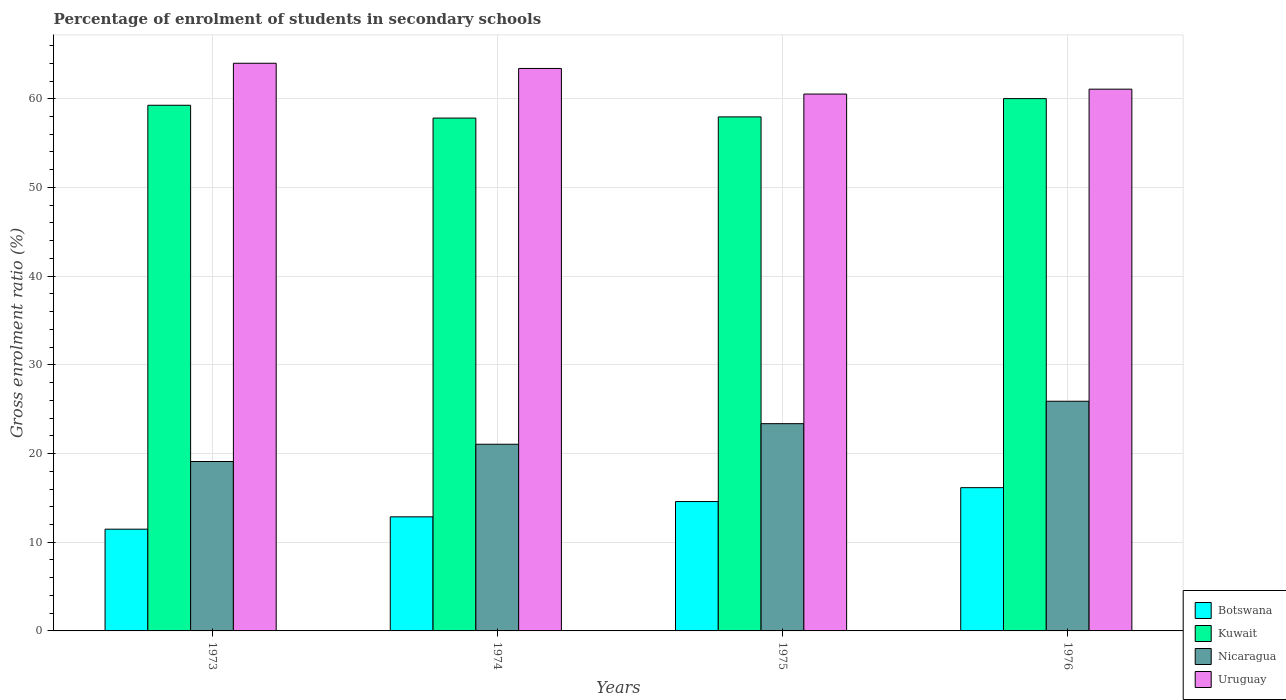How many groups of bars are there?
Give a very brief answer. 4. Are the number of bars on each tick of the X-axis equal?
Make the answer very short. Yes. How many bars are there on the 1st tick from the left?
Offer a terse response. 4. How many bars are there on the 3rd tick from the right?
Ensure brevity in your answer.  4. What is the label of the 1st group of bars from the left?
Give a very brief answer. 1973. In how many cases, is the number of bars for a given year not equal to the number of legend labels?
Offer a terse response. 0. What is the percentage of students enrolled in secondary schools in Kuwait in 1976?
Ensure brevity in your answer.  60.01. Across all years, what is the maximum percentage of students enrolled in secondary schools in Botswana?
Offer a terse response. 16.15. Across all years, what is the minimum percentage of students enrolled in secondary schools in Nicaragua?
Provide a succinct answer. 19.1. In which year was the percentage of students enrolled in secondary schools in Kuwait maximum?
Provide a succinct answer. 1976. In which year was the percentage of students enrolled in secondary schools in Uruguay minimum?
Provide a succinct answer. 1975. What is the total percentage of students enrolled in secondary schools in Uruguay in the graph?
Keep it short and to the point. 249.03. What is the difference between the percentage of students enrolled in secondary schools in Uruguay in 1973 and that in 1976?
Give a very brief answer. 2.92. What is the difference between the percentage of students enrolled in secondary schools in Nicaragua in 1975 and the percentage of students enrolled in secondary schools in Botswana in 1974?
Your answer should be very brief. 10.51. What is the average percentage of students enrolled in secondary schools in Uruguay per year?
Provide a short and direct response. 62.26. In the year 1975, what is the difference between the percentage of students enrolled in secondary schools in Botswana and percentage of students enrolled in secondary schools in Nicaragua?
Give a very brief answer. -8.78. What is the ratio of the percentage of students enrolled in secondary schools in Nicaragua in 1974 to that in 1976?
Keep it short and to the point. 0.81. Is the difference between the percentage of students enrolled in secondary schools in Botswana in 1975 and 1976 greater than the difference between the percentage of students enrolled in secondary schools in Nicaragua in 1975 and 1976?
Ensure brevity in your answer.  Yes. What is the difference between the highest and the second highest percentage of students enrolled in secondary schools in Nicaragua?
Offer a very short reply. 2.53. What is the difference between the highest and the lowest percentage of students enrolled in secondary schools in Botswana?
Provide a succinct answer. 4.68. Is the sum of the percentage of students enrolled in secondary schools in Uruguay in 1974 and 1976 greater than the maximum percentage of students enrolled in secondary schools in Kuwait across all years?
Offer a very short reply. Yes. Is it the case that in every year, the sum of the percentage of students enrolled in secondary schools in Kuwait and percentage of students enrolled in secondary schools in Nicaragua is greater than the sum of percentage of students enrolled in secondary schools in Botswana and percentage of students enrolled in secondary schools in Uruguay?
Your answer should be compact. Yes. What does the 3rd bar from the left in 1976 represents?
Keep it short and to the point. Nicaragua. What does the 4th bar from the right in 1975 represents?
Make the answer very short. Botswana. How are the legend labels stacked?
Your response must be concise. Vertical. What is the title of the graph?
Make the answer very short. Percentage of enrolment of students in secondary schools. Does "High income: OECD" appear as one of the legend labels in the graph?
Offer a very short reply. No. What is the Gross enrolment ratio (%) of Botswana in 1973?
Your answer should be compact. 11.47. What is the Gross enrolment ratio (%) of Kuwait in 1973?
Your response must be concise. 59.27. What is the Gross enrolment ratio (%) in Nicaragua in 1973?
Keep it short and to the point. 19.1. What is the Gross enrolment ratio (%) of Uruguay in 1973?
Make the answer very short. 64. What is the Gross enrolment ratio (%) in Botswana in 1974?
Your answer should be very brief. 12.86. What is the Gross enrolment ratio (%) in Kuwait in 1974?
Your answer should be compact. 57.82. What is the Gross enrolment ratio (%) of Nicaragua in 1974?
Make the answer very short. 21.05. What is the Gross enrolment ratio (%) of Uruguay in 1974?
Provide a short and direct response. 63.41. What is the Gross enrolment ratio (%) in Botswana in 1975?
Make the answer very short. 14.59. What is the Gross enrolment ratio (%) in Kuwait in 1975?
Offer a very short reply. 57.95. What is the Gross enrolment ratio (%) in Nicaragua in 1975?
Your answer should be compact. 23.37. What is the Gross enrolment ratio (%) of Uruguay in 1975?
Your answer should be very brief. 60.53. What is the Gross enrolment ratio (%) of Botswana in 1976?
Offer a very short reply. 16.15. What is the Gross enrolment ratio (%) of Kuwait in 1976?
Your answer should be compact. 60.01. What is the Gross enrolment ratio (%) of Nicaragua in 1976?
Provide a short and direct response. 25.89. What is the Gross enrolment ratio (%) in Uruguay in 1976?
Keep it short and to the point. 61.08. Across all years, what is the maximum Gross enrolment ratio (%) of Botswana?
Give a very brief answer. 16.15. Across all years, what is the maximum Gross enrolment ratio (%) of Kuwait?
Your response must be concise. 60.01. Across all years, what is the maximum Gross enrolment ratio (%) of Nicaragua?
Offer a terse response. 25.89. Across all years, what is the maximum Gross enrolment ratio (%) of Uruguay?
Provide a succinct answer. 64. Across all years, what is the minimum Gross enrolment ratio (%) in Botswana?
Ensure brevity in your answer.  11.47. Across all years, what is the minimum Gross enrolment ratio (%) of Kuwait?
Give a very brief answer. 57.82. Across all years, what is the minimum Gross enrolment ratio (%) of Nicaragua?
Ensure brevity in your answer.  19.1. Across all years, what is the minimum Gross enrolment ratio (%) of Uruguay?
Your answer should be compact. 60.53. What is the total Gross enrolment ratio (%) in Botswana in the graph?
Ensure brevity in your answer.  55.07. What is the total Gross enrolment ratio (%) in Kuwait in the graph?
Offer a terse response. 235.06. What is the total Gross enrolment ratio (%) in Nicaragua in the graph?
Offer a terse response. 89.41. What is the total Gross enrolment ratio (%) in Uruguay in the graph?
Give a very brief answer. 249.03. What is the difference between the Gross enrolment ratio (%) in Botswana in 1973 and that in 1974?
Your response must be concise. -1.39. What is the difference between the Gross enrolment ratio (%) of Kuwait in 1973 and that in 1974?
Provide a short and direct response. 1.44. What is the difference between the Gross enrolment ratio (%) in Nicaragua in 1973 and that in 1974?
Make the answer very short. -1.95. What is the difference between the Gross enrolment ratio (%) of Uruguay in 1973 and that in 1974?
Make the answer very short. 0.59. What is the difference between the Gross enrolment ratio (%) in Botswana in 1973 and that in 1975?
Keep it short and to the point. -3.12. What is the difference between the Gross enrolment ratio (%) of Kuwait in 1973 and that in 1975?
Provide a short and direct response. 1.31. What is the difference between the Gross enrolment ratio (%) of Nicaragua in 1973 and that in 1975?
Give a very brief answer. -4.27. What is the difference between the Gross enrolment ratio (%) of Uruguay in 1973 and that in 1975?
Your answer should be compact. 3.47. What is the difference between the Gross enrolment ratio (%) in Botswana in 1973 and that in 1976?
Provide a short and direct response. -4.68. What is the difference between the Gross enrolment ratio (%) in Kuwait in 1973 and that in 1976?
Give a very brief answer. -0.75. What is the difference between the Gross enrolment ratio (%) of Nicaragua in 1973 and that in 1976?
Offer a very short reply. -6.79. What is the difference between the Gross enrolment ratio (%) in Uruguay in 1973 and that in 1976?
Offer a terse response. 2.92. What is the difference between the Gross enrolment ratio (%) in Botswana in 1974 and that in 1975?
Your answer should be compact. -1.72. What is the difference between the Gross enrolment ratio (%) in Kuwait in 1974 and that in 1975?
Provide a succinct answer. -0.13. What is the difference between the Gross enrolment ratio (%) in Nicaragua in 1974 and that in 1975?
Provide a succinct answer. -2.32. What is the difference between the Gross enrolment ratio (%) in Uruguay in 1974 and that in 1975?
Make the answer very short. 2.88. What is the difference between the Gross enrolment ratio (%) in Botswana in 1974 and that in 1976?
Provide a succinct answer. -3.29. What is the difference between the Gross enrolment ratio (%) of Kuwait in 1974 and that in 1976?
Ensure brevity in your answer.  -2.19. What is the difference between the Gross enrolment ratio (%) in Nicaragua in 1974 and that in 1976?
Provide a succinct answer. -4.85. What is the difference between the Gross enrolment ratio (%) of Uruguay in 1974 and that in 1976?
Your response must be concise. 2.33. What is the difference between the Gross enrolment ratio (%) of Botswana in 1975 and that in 1976?
Make the answer very short. -1.56. What is the difference between the Gross enrolment ratio (%) in Kuwait in 1975 and that in 1976?
Your answer should be very brief. -2.06. What is the difference between the Gross enrolment ratio (%) of Nicaragua in 1975 and that in 1976?
Your answer should be very brief. -2.53. What is the difference between the Gross enrolment ratio (%) of Uruguay in 1975 and that in 1976?
Provide a succinct answer. -0.55. What is the difference between the Gross enrolment ratio (%) in Botswana in 1973 and the Gross enrolment ratio (%) in Kuwait in 1974?
Your response must be concise. -46.35. What is the difference between the Gross enrolment ratio (%) of Botswana in 1973 and the Gross enrolment ratio (%) of Nicaragua in 1974?
Provide a succinct answer. -9.58. What is the difference between the Gross enrolment ratio (%) of Botswana in 1973 and the Gross enrolment ratio (%) of Uruguay in 1974?
Offer a terse response. -51.94. What is the difference between the Gross enrolment ratio (%) in Kuwait in 1973 and the Gross enrolment ratio (%) in Nicaragua in 1974?
Provide a succinct answer. 38.22. What is the difference between the Gross enrolment ratio (%) in Kuwait in 1973 and the Gross enrolment ratio (%) in Uruguay in 1974?
Ensure brevity in your answer.  -4.15. What is the difference between the Gross enrolment ratio (%) in Nicaragua in 1973 and the Gross enrolment ratio (%) in Uruguay in 1974?
Offer a very short reply. -44.31. What is the difference between the Gross enrolment ratio (%) in Botswana in 1973 and the Gross enrolment ratio (%) in Kuwait in 1975?
Make the answer very short. -46.48. What is the difference between the Gross enrolment ratio (%) of Botswana in 1973 and the Gross enrolment ratio (%) of Nicaragua in 1975?
Keep it short and to the point. -11.9. What is the difference between the Gross enrolment ratio (%) in Botswana in 1973 and the Gross enrolment ratio (%) in Uruguay in 1975?
Your answer should be very brief. -49.06. What is the difference between the Gross enrolment ratio (%) in Kuwait in 1973 and the Gross enrolment ratio (%) in Nicaragua in 1975?
Provide a succinct answer. 35.9. What is the difference between the Gross enrolment ratio (%) of Kuwait in 1973 and the Gross enrolment ratio (%) of Uruguay in 1975?
Your response must be concise. -1.26. What is the difference between the Gross enrolment ratio (%) in Nicaragua in 1973 and the Gross enrolment ratio (%) in Uruguay in 1975?
Keep it short and to the point. -41.43. What is the difference between the Gross enrolment ratio (%) of Botswana in 1973 and the Gross enrolment ratio (%) of Kuwait in 1976?
Keep it short and to the point. -48.54. What is the difference between the Gross enrolment ratio (%) of Botswana in 1973 and the Gross enrolment ratio (%) of Nicaragua in 1976?
Keep it short and to the point. -14.42. What is the difference between the Gross enrolment ratio (%) in Botswana in 1973 and the Gross enrolment ratio (%) in Uruguay in 1976?
Ensure brevity in your answer.  -49.61. What is the difference between the Gross enrolment ratio (%) in Kuwait in 1973 and the Gross enrolment ratio (%) in Nicaragua in 1976?
Make the answer very short. 33.37. What is the difference between the Gross enrolment ratio (%) of Kuwait in 1973 and the Gross enrolment ratio (%) of Uruguay in 1976?
Ensure brevity in your answer.  -1.82. What is the difference between the Gross enrolment ratio (%) in Nicaragua in 1973 and the Gross enrolment ratio (%) in Uruguay in 1976?
Make the answer very short. -41.98. What is the difference between the Gross enrolment ratio (%) of Botswana in 1974 and the Gross enrolment ratio (%) of Kuwait in 1975?
Offer a terse response. -45.09. What is the difference between the Gross enrolment ratio (%) in Botswana in 1974 and the Gross enrolment ratio (%) in Nicaragua in 1975?
Your answer should be compact. -10.51. What is the difference between the Gross enrolment ratio (%) in Botswana in 1974 and the Gross enrolment ratio (%) in Uruguay in 1975?
Your answer should be very brief. -47.67. What is the difference between the Gross enrolment ratio (%) in Kuwait in 1974 and the Gross enrolment ratio (%) in Nicaragua in 1975?
Offer a very short reply. 34.45. What is the difference between the Gross enrolment ratio (%) of Kuwait in 1974 and the Gross enrolment ratio (%) of Uruguay in 1975?
Keep it short and to the point. -2.71. What is the difference between the Gross enrolment ratio (%) of Nicaragua in 1974 and the Gross enrolment ratio (%) of Uruguay in 1975?
Make the answer very short. -39.48. What is the difference between the Gross enrolment ratio (%) in Botswana in 1974 and the Gross enrolment ratio (%) in Kuwait in 1976?
Provide a succinct answer. -47.15. What is the difference between the Gross enrolment ratio (%) in Botswana in 1974 and the Gross enrolment ratio (%) in Nicaragua in 1976?
Offer a terse response. -13.03. What is the difference between the Gross enrolment ratio (%) in Botswana in 1974 and the Gross enrolment ratio (%) in Uruguay in 1976?
Make the answer very short. -48.22. What is the difference between the Gross enrolment ratio (%) of Kuwait in 1974 and the Gross enrolment ratio (%) of Nicaragua in 1976?
Offer a very short reply. 31.93. What is the difference between the Gross enrolment ratio (%) of Kuwait in 1974 and the Gross enrolment ratio (%) of Uruguay in 1976?
Provide a short and direct response. -3.26. What is the difference between the Gross enrolment ratio (%) of Nicaragua in 1974 and the Gross enrolment ratio (%) of Uruguay in 1976?
Keep it short and to the point. -40.03. What is the difference between the Gross enrolment ratio (%) in Botswana in 1975 and the Gross enrolment ratio (%) in Kuwait in 1976?
Ensure brevity in your answer.  -45.43. What is the difference between the Gross enrolment ratio (%) in Botswana in 1975 and the Gross enrolment ratio (%) in Nicaragua in 1976?
Give a very brief answer. -11.31. What is the difference between the Gross enrolment ratio (%) in Botswana in 1975 and the Gross enrolment ratio (%) in Uruguay in 1976?
Offer a very short reply. -46.49. What is the difference between the Gross enrolment ratio (%) of Kuwait in 1975 and the Gross enrolment ratio (%) of Nicaragua in 1976?
Provide a short and direct response. 32.06. What is the difference between the Gross enrolment ratio (%) in Kuwait in 1975 and the Gross enrolment ratio (%) in Uruguay in 1976?
Your answer should be very brief. -3.13. What is the difference between the Gross enrolment ratio (%) in Nicaragua in 1975 and the Gross enrolment ratio (%) in Uruguay in 1976?
Make the answer very short. -37.71. What is the average Gross enrolment ratio (%) in Botswana per year?
Keep it short and to the point. 13.77. What is the average Gross enrolment ratio (%) of Kuwait per year?
Keep it short and to the point. 58.76. What is the average Gross enrolment ratio (%) in Nicaragua per year?
Offer a terse response. 22.35. What is the average Gross enrolment ratio (%) of Uruguay per year?
Your answer should be very brief. 62.26. In the year 1973, what is the difference between the Gross enrolment ratio (%) of Botswana and Gross enrolment ratio (%) of Kuwait?
Your answer should be very brief. -47.8. In the year 1973, what is the difference between the Gross enrolment ratio (%) of Botswana and Gross enrolment ratio (%) of Nicaragua?
Your answer should be compact. -7.63. In the year 1973, what is the difference between the Gross enrolment ratio (%) of Botswana and Gross enrolment ratio (%) of Uruguay?
Make the answer very short. -52.53. In the year 1973, what is the difference between the Gross enrolment ratio (%) in Kuwait and Gross enrolment ratio (%) in Nicaragua?
Ensure brevity in your answer.  40.17. In the year 1973, what is the difference between the Gross enrolment ratio (%) of Kuwait and Gross enrolment ratio (%) of Uruguay?
Your response must be concise. -4.74. In the year 1973, what is the difference between the Gross enrolment ratio (%) of Nicaragua and Gross enrolment ratio (%) of Uruguay?
Make the answer very short. -44.9. In the year 1974, what is the difference between the Gross enrolment ratio (%) in Botswana and Gross enrolment ratio (%) in Kuwait?
Keep it short and to the point. -44.96. In the year 1974, what is the difference between the Gross enrolment ratio (%) in Botswana and Gross enrolment ratio (%) in Nicaragua?
Make the answer very short. -8.19. In the year 1974, what is the difference between the Gross enrolment ratio (%) in Botswana and Gross enrolment ratio (%) in Uruguay?
Provide a succinct answer. -50.55. In the year 1974, what is the difference between the Gross enrolment ratio (%) in Kuwait and Gross enrolment ratio (%) in Nicaragua?
Your response must be concise. 36.77. In the year 1974, what is the difference between the Gross enrolment ratio (%) in Kuwait and Gross enrolment ratio (%) in Uruguay?
Your answer should be very brief. -5.59. In the year 1974, what is the difference between the Gross enrolment ratio (%) in Nicaragua and Gross enrolment ratio (%) in Uruguay?
Keep it short and to the point. -42.37. In the year 1975, what is the difference between the Gross enrolment ratio (%) of Botswana and Gross enrolment ratio (%) of Kuwait?
Ensure brevity in your answer.  -43.37. In the year 1975, what is the difference between the Gross enrolment ratio (%) in Botswana and Gross enrolment ratio (%) in Nicaragua?
Give a very brief answer. -8.78. In the year 1975, what is the difference between the Gross enrolment ratio (%) in Botswana and Gross enrolment ratio (%) in Uruguay?
Make the answer very short. -45.94. In the year 1975, what is the difference between the Gross enrolment ratio (%) in Kuwait and Gross enrolment ratio (%) in Nicaragua?
Your answer should be compact. 34.59. In the year 1975, what is the difference between the Gross enrolment ratio (%) in Kuwait and Gross enrolment ratio (%) in Uruguay?
Ensure brevity in your answer.  -2.58. In the year 1975, what is the difference between the Gross enrolment ratio (%) in Nicaragua and Gross enrolment ratio (%) in Uruguay?
Make the answer very short. -37.16. In the year 1976, what is the difference between the Gross enrolment ratio (%) of Botswana and Gross enrolment ratio (%) of Kuwait?
Provide a succinct answer. -43.86. In the year 1976, what is the difference between the Gross enrolment ratio (%) of Botswana and Gross enrolment ratio (%) of Nicaragua?
Offer a terse response. -9.74. In the year 1976, what is the difference between the Gross enrolment ratio (%) of Botswana and Gross enrolment ratio (%) of Uruguay?
Make the answer very short. -44.93. In the year 1976, what is the difference between the Gross enrolment ratio (%) of Kuwait and Gross enrolment ratio (%) of Nicaragua?
Provide a short and direct response. 34.12. In the year 1976, what is the difference between the Gross enrolment ratio (%) in Kuwait and Gross enrolment ratio (%) in Uruguay?
Your answer should be very brief. -1.07. In the year 1976, what is the difference between the Gross enrolment ratio (%) in Nicaragua and Gross enrolment ratio (%) in Uruguay?
Offer a very short reply. -35.19. What is the ratio of the Gross enrolment ratio (%) in Botswana in 1973 to that in 1974?
Make the answer very short. 0.89. What is the ratio of the Gross enrolment ratio (%) of Nicaragua in 1973 to that in 1974?
Offer a terse response. 0.91. What is the ratio of the Gross enrolment ratio (%) in Uruguay in 1973 to that in 1974?
Your response must be concise. 1.01. What is the ratio of the Gross enrolment ratio (%) in Botswana in 1973 to that in 1975?
Your answer should be very brief. 0.79. What is the ratio of the Gross enrolment ratio (%) of Kuwait in 1973 to that in 1975?
Your response must be concise. 1.02. What is the ratio of the Gross enrolment ratio (%) in Nicaragua in 1973 to that in 1975?
Offer a terse response. 0.82. What is the ratio of the Gross enrolment ratio (%) in Uruguay in 1973 to that in 1975?
Your answer should be very brief. 1.06. What is the ratio of the Gross enrolment ratio (%) in Botswana in 1973 to that in 1976?
Ensure brevity in your answer.  0.71. What is the ratio of the Gross enrolment ratio (%) in Kuwait in 1973 to that in 1976?
Offer a very short reply. 0.99. What is the ratio of the Gross enrolment ratio (%) in Nicaragua in 1973 to that in 1976?
Ensure brevity in your answer.  0.74. What is the ratio of the Gross enrolment ratio (%) of Uruguay in 1973 to that in 1976?
Offer a terse response. 1.05. What is the ratio of the Gross enrolment ratio (%) of Botswana in 1974 to that in 1975?
Ensure brevity in your answer.  0.88. What is the ratio of the Gross enrolment ratio (%) of Nicaragua in 1974 to that in 1975?
Your response must be concise. 0.9. What is the ratio of the Gross enrolment ratio (%) in Uruguay in 1974 to that in 1975?
Keep it short and to the point. 1.05. What is the ratio of the Gross enrolment ratio (%) of Botswana in 1974 to that in 1976?
Give a very brief answer. 0.8. What is the ratio of the Gross enrolment ratio (%) of Kuwait in 1974 to that in 1976?
Keep it short and to the point. 0.96. What is the ratio of the Gross enrolment ratio (%) in Nicaragua in 1974 to that in 1976?
Ensure brevity in your answer.  0.81. What is the ratio of the Gross enrolment ratio (%) of Uruguay in 1974 to that in 1976?
Provide a short and direct response. 1.04. What is the ratio of the Gross enrolment ratio (%) of Botswana in 1975 to that in 1976?
Offer a very short reply. 0.9. What is the ratio of the Gross enrolment ratio (%) in Kuwait in 1975 to that in 1976?
Make the answer very short. 0.97. What is the ratio of the Gross enrolment ratio (%) in Nicaragua in 1975 to that in 1976?
Ensure brevity in your answer.  0.9. What is the ratio of the Gross enrolment ratio (%) of Uruguay in 1975 to that in 1976?
Ensure brevity in your answer.  0.99. What is the difference between the highest and the second highest Gross enrolment ratio (%) in Botswana?
Ensure brevity in your answer.  1.56. What is the difference between the highest and the second highest Gross enrolment ratio (%) of Kuwait?
Make the answer very short. 0.75. What is the difference between the highest and the second highest Gross enrolment ratio (%) in Nicaragua?
Keep it short and to the point. 2.53. What is the difference between the highest and the second highest Gross enrolment ratio (%) of Uruguay?
Your response must be concise. 0.59. What is the difference between the highest and the lowest Gross enrolment ratio (%) of Botswana?
Your response must be concise. 4.68. What is the difference between the highest and the lowest Gross enrolment ratio (%) in Kuwait?
Your answer should be compact. 2.19. What is the difference between the highest and the lowest Gross enrolment ratio (%) in Nicaragua?
Ensure brevity in your answer.  6.79. What is the difference between the highest and the lowest Gross enrolment ratio (%) of Uruguay?
Provide a short and direct response. 3.47. 